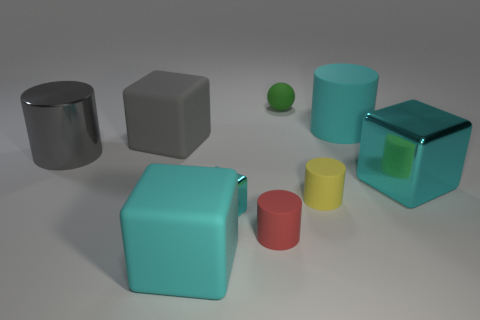Is the gray block made of the same material as the large cylinder right of the yellow rubber cylinder?
Your response must be concise. Yes. What number of things are either yellow objects or big gray metal balls?
Your answer should be compact. 1. Is there a tiny red metallic thing?
Provide a short and direct response. No. There is a tiny thing behind the big cube right of the small green matte object; what shape is it?
Your response must be concise. Sphere. What number of objects are big matte cubes that are in front of the big gray metal thing or big cyan matte objects that are in front of the yellow thing?
Give a very brief answer. 1. There is a cyan cylinder that is the same size as the gray matte cube; what is its material?
Provide a short and direct response. Rubber. What color is the big rubber cylinder?
Give a very brief answer. Cyan. There is a cylinder that is both left of the cyan cylinder and behind the yellow rubber thing; what material is it?
Offer a terse response. Metal. Are there any metallic cylinders that are behind the small yellow matte cylinder in front of the big cylinder that is behind the big shiny cylinder?
Offer a very short reply. Yes. What size is the rubber cylinder that is the same color as the small cube?
Your answer should be compact. Large. 